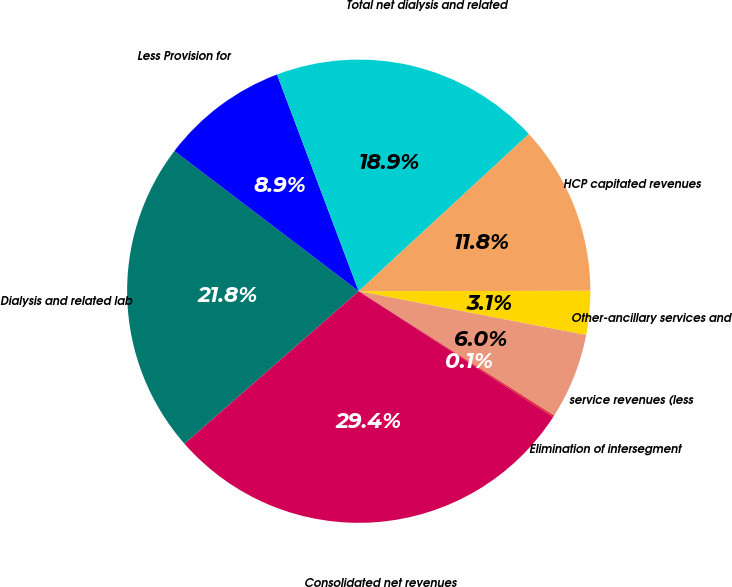Convert chart. <chart><loc_0><loc_0><loc_500><loc_500><pie_chart><fcel>Dialysis and related lab<fcel>Less Provision for<fcel>Total net dialysis and related<fcel>HCP capitated revenues<fcel>Other-ancillary services and<fcel>service revenues (less<fcel>Elimination of intersegment<fcel>Consolidated net revenues<nl><fcel>21.8%<fcel>8.91%<fcel>18.87%<fcel>11.84%<fcel>3.06%<fcel>5.99%<fcel>0.13%<fcel>29.4%<nl></chart> 